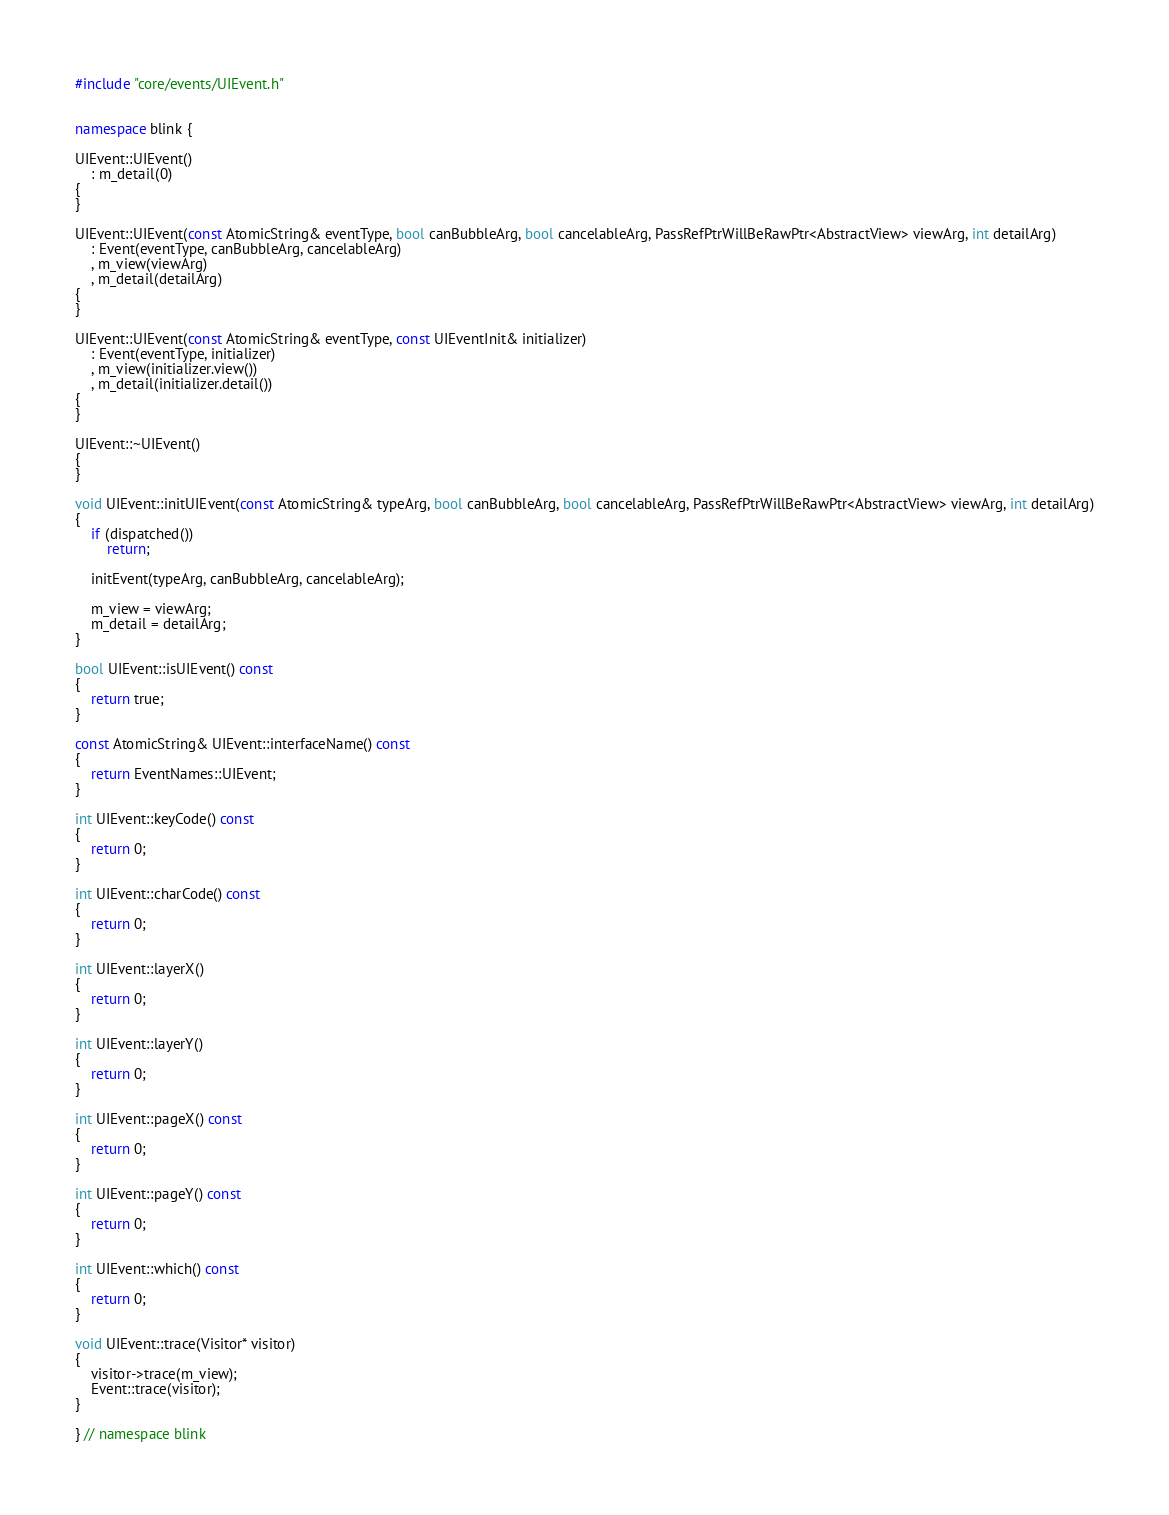<code> <loc_0><loc_0><loc_500><loc_500><_C++_>#include "core/events/UIEvent.h"


namespace blink {

UIEvent::UIEvent()
    : m_detail(0)
{
}

UIEvent::UIEvent(const AtomicString& eventType, bool canBubbleArg, bool cancelableArg, PassRefPtrWillBeRawPtr<AbstractView> viewArg, int detailArg)
    : Event(eventType, canBubbleArg, cancelableArg)
    , m_view(viewArg)
    , m_detail(detailArg)
{
}

UIEvent::UIEvent(const AtomicString& eventType, const UIEventInit& initializer)
    : Event(eventType, initializer)
    , m_view(initializer.view())
    , m_detail(initializer.detail())
{
}

UIEvent::~UIEvent()
{
}

void UIEvent::initUIEvent(const AtomicString& typeArg, bool canBubbleArg, bool cancelableArg, PassRefPtrWillBeRawPtr<AbstractView> viewArg, int detailArg)
{
    if (dispatched())
        return;

    initEvent(typeArg, canBubbleArg, cancelableArg);

    m_view = viewArg;
    m_detail = detailArg;
}

bool UIEvent::isUIEvent() const
{
    return true;
}

const AtomicString& UIEvent::interfaceName() const
{
    return EventNames::UIEvent;
}

int UIEvent::keyCode() const
{
    return 0;
}

int UIEvent::charCode() const
{
    return 0;
}

int UIEvent::layerX()
{
    return 0;
}

int UIEvent::layerY()
{
    return 0;
}

int UIEvent::pageX() const
{
    return 0;
}

int UIEvent::pageY() const
{
    return 0;
}

int UIEvent::which() const
{
    return 0;
}

void UIEvent::trace(Visitor* visitor)
{
    visitor->trace(m_view);
    Event::trace(visitor);
}

} // namespace blink
</code> 